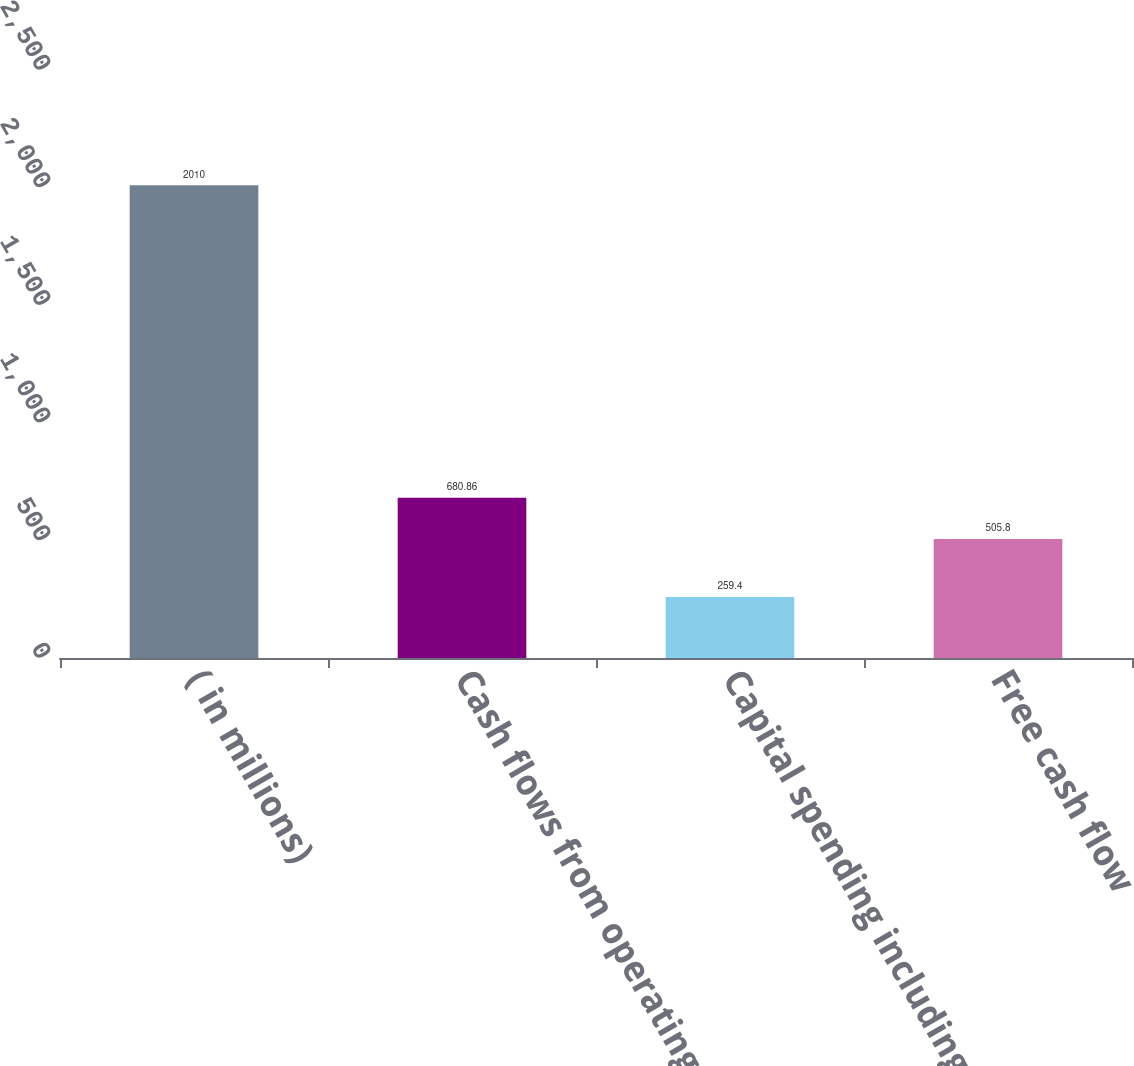Convert chart to OTSL. <chart><loc_0><loc_0><loc_500><loc_500><bar_chart><fcel>( in millions)<fcel>Cash flows from operating<fcel>Capital spending including<fcel>Free cash flow<nl><fcel>2010<fcel>680.86<fcel>259.4<fcel>505.8<nl></chart> 